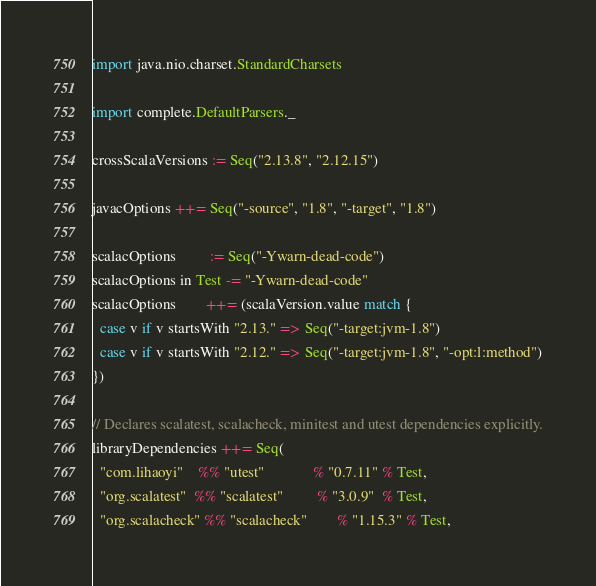Convert code to text. <code><loc_0><loc_0><loc_500><loc_500><_Scala_>import java.nio.charset.StandardCharsets

import complete.DefaultParsers._

crossScalaVersions := Seq("2.13.8", "2.12.15")

javacOptions ++= Seq("-source", "1.8", "-target", "1.8")

scalacOptions         := Seq("-Ywarn-dead-code")
scalacOptions in Test -= "-Ywarn-dead-code"
scalacOptions        ++= (scalaVersion.value match {
  case v if v startsWith "2.13." => Seq("-target:jvm-1.8")
  case v if v startsWith "2.12." => Seq("-target:jvm-1.8", "-opt:l:method")
})

// Declares scalatest, scalacheck, minitest and utest dependencies explicitly.
libraryDependencies ++= Seq(
  "com.lihaoyi"    %% "utest"             % "0.7.11" % Test,
  "org.scalatest"  %% "scalatest"         % "3.0.9"  % Test,
  "org.scalacheck" %% "scalacheck"        % "1.15.3" % Test,</code> 